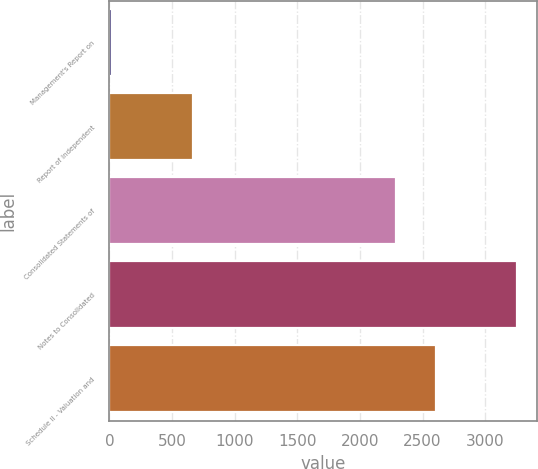<chart> <loc_0><loc_0><loc_500><loc_500><bar_chart><fcel>Management's Report on<fcel>Report of Independent<fcel>Consolidated Statements of<fcel>Notes to Consolidated<fcel>Schedule II - Valuation and<nl><fcel>24<fcel>669.6<fcel>2283.6<fcel>3252<fcel>2606.4<nl></chart> 